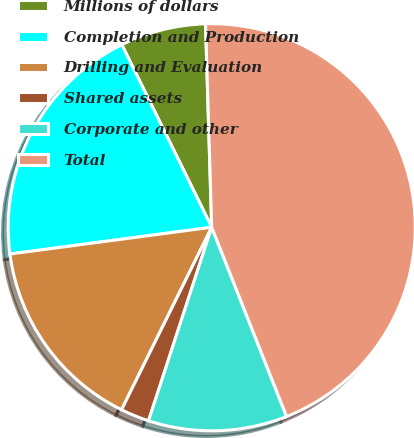Convert chart to OTSL. <chart><loc_0><loc_0><loc_500><loc_500><pie_chart><fcel>Millions of dollars<fcel>Completion and Production<fcel>Drilling and Evaluation<fcel>Shared assets<fcel>Corporate and other<fcel>Total<nl><fcel>6.8%<fcel>19.82%<fcel>15.6%<fcel>2.28%<fcel>11.02%<fcel>44.49%<nl></chart> 